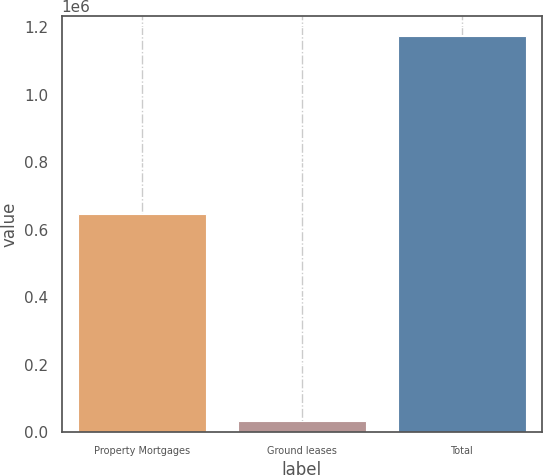Convert chart. <chart><loc_0><loc_0><loc_500><loc_500><bar_chart><fcel>Property Mortgages<fcel>Ground leases<fcel>Total<nl><fcel>647776<fcel>33429<fcel>1.17461e+06<nl></chart> 